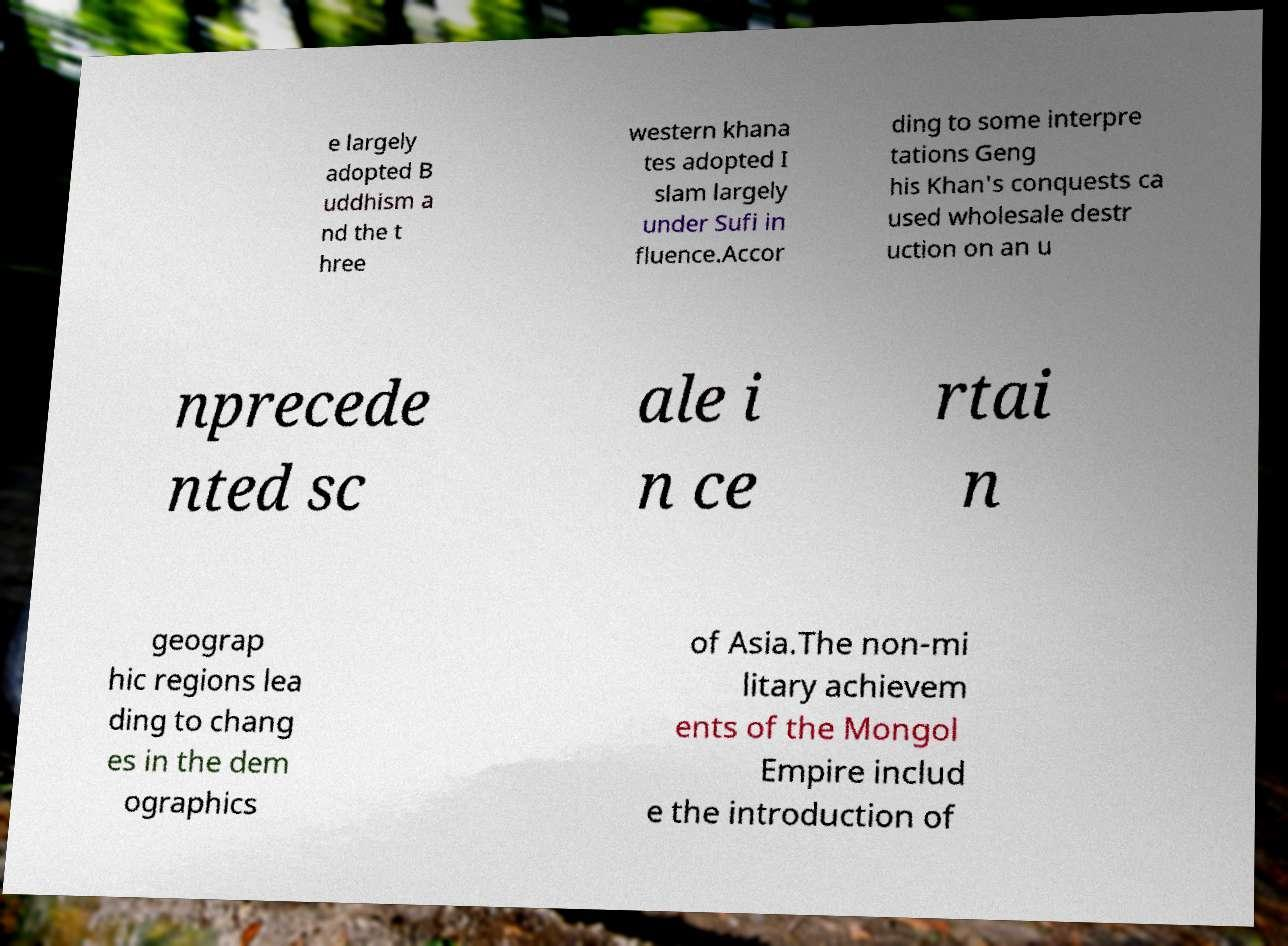I need the written content from this picture converted into text. Can you do that? e largely adopted B uddhism a nd the t hree western khana tes adopted I slam largely under Sufi in fluence.Accor ding to some interpre tations Geng his Khan's conquests ca used wholesale destr uction on an u nprecede nted sc ale i n ce rtai n geograp hic regions lea ding to chang es in the dem ographics of Asia.The non-mi litary achievem ents of the Mongol Empire includ e the introduction of 